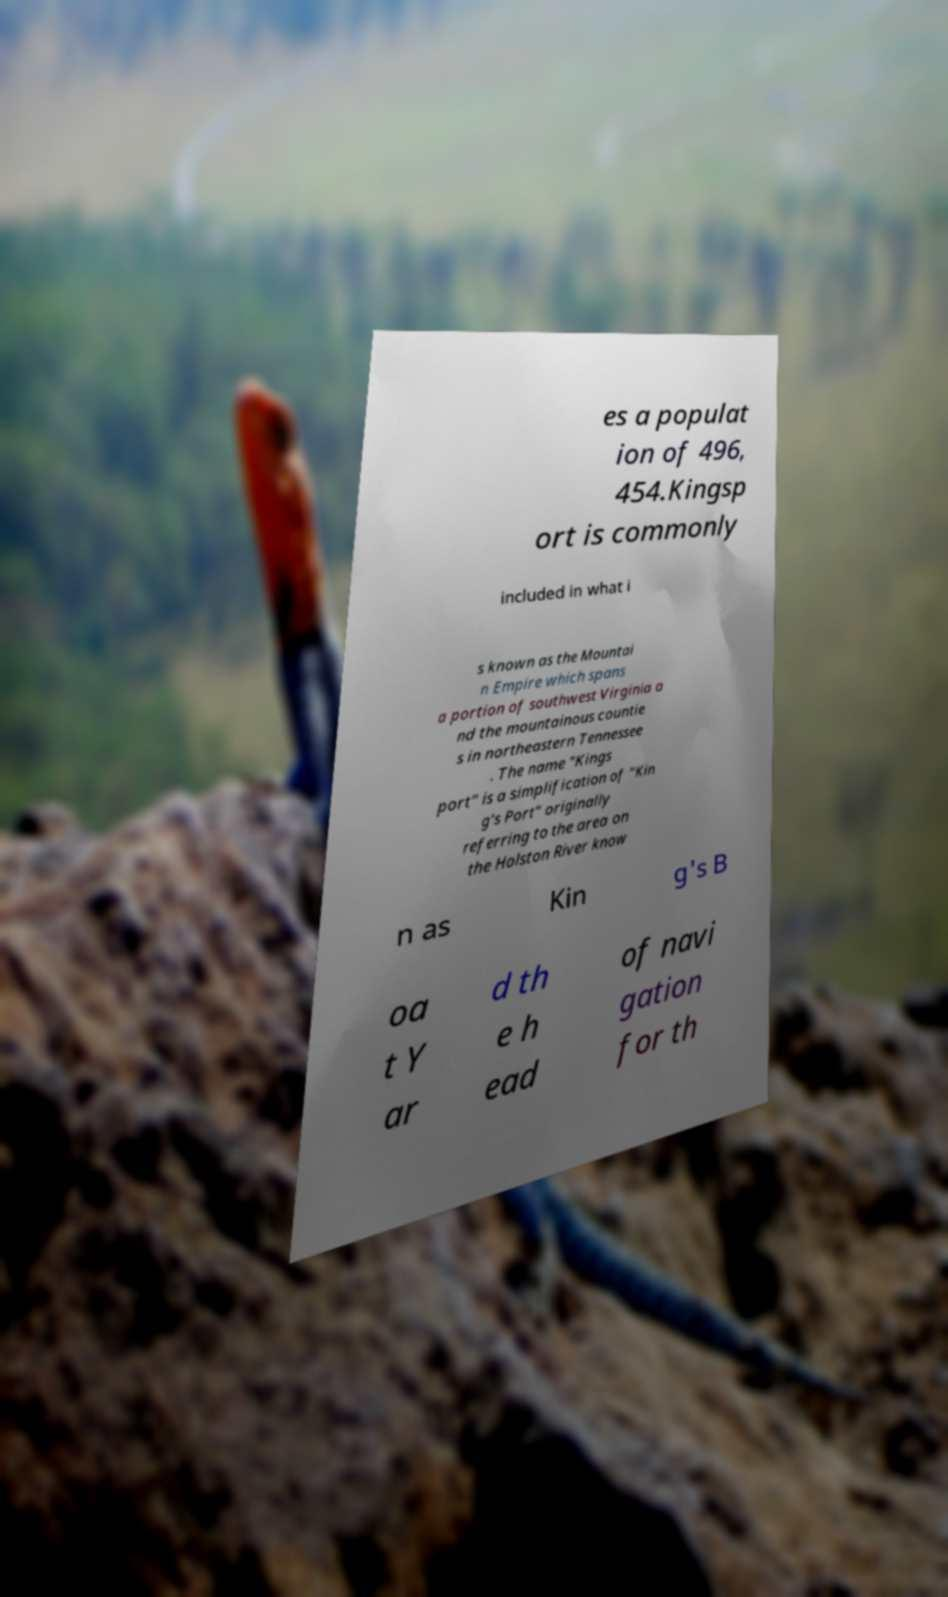Can you read and provide the text displayed in the image?This photo seems to have some interesting text. Can you extract and type it out for me? es a populat ion of 496, 454.Kingsp ort is commonly included in what i s known as the Mountai n Empire which spans a portion of southwest Virginia a nd the mountainous countie s in northeastern Tennessee . The name "Kings port" is a simplification of "Kin g's Port" originally referring to the area on the Holston River know n as Kin g's B oa t Y ar d th e h ead of navi gation for th 